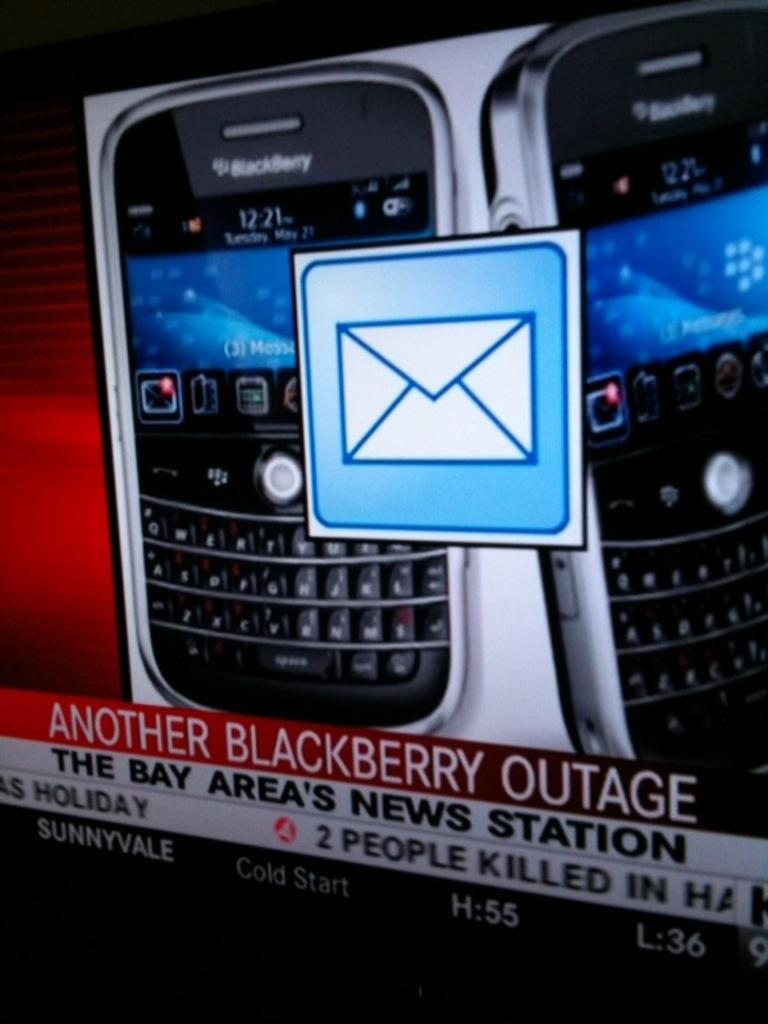What type of electronic devices are present in the image? There are two blackberry mobile phones in the image. What message is displayed in the image? The words "ANOTHER BLACKBERRY OUTAGE" are printed in red color in the image. What type of scene is depicted in the image? The image does not depict a scene; it features two blackberry mobile phones and a message about an outage. Is there any indication of a disease in the image? There is no mention or indication of a disease in the image. 